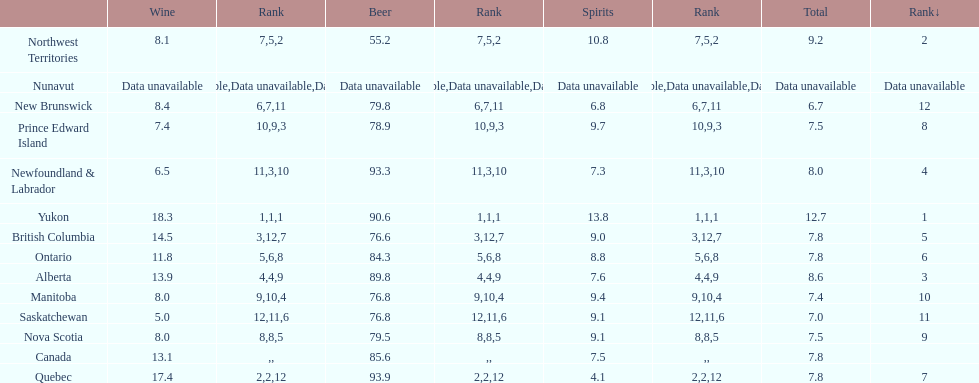Which province is the top consumer of wine? Yukon. 